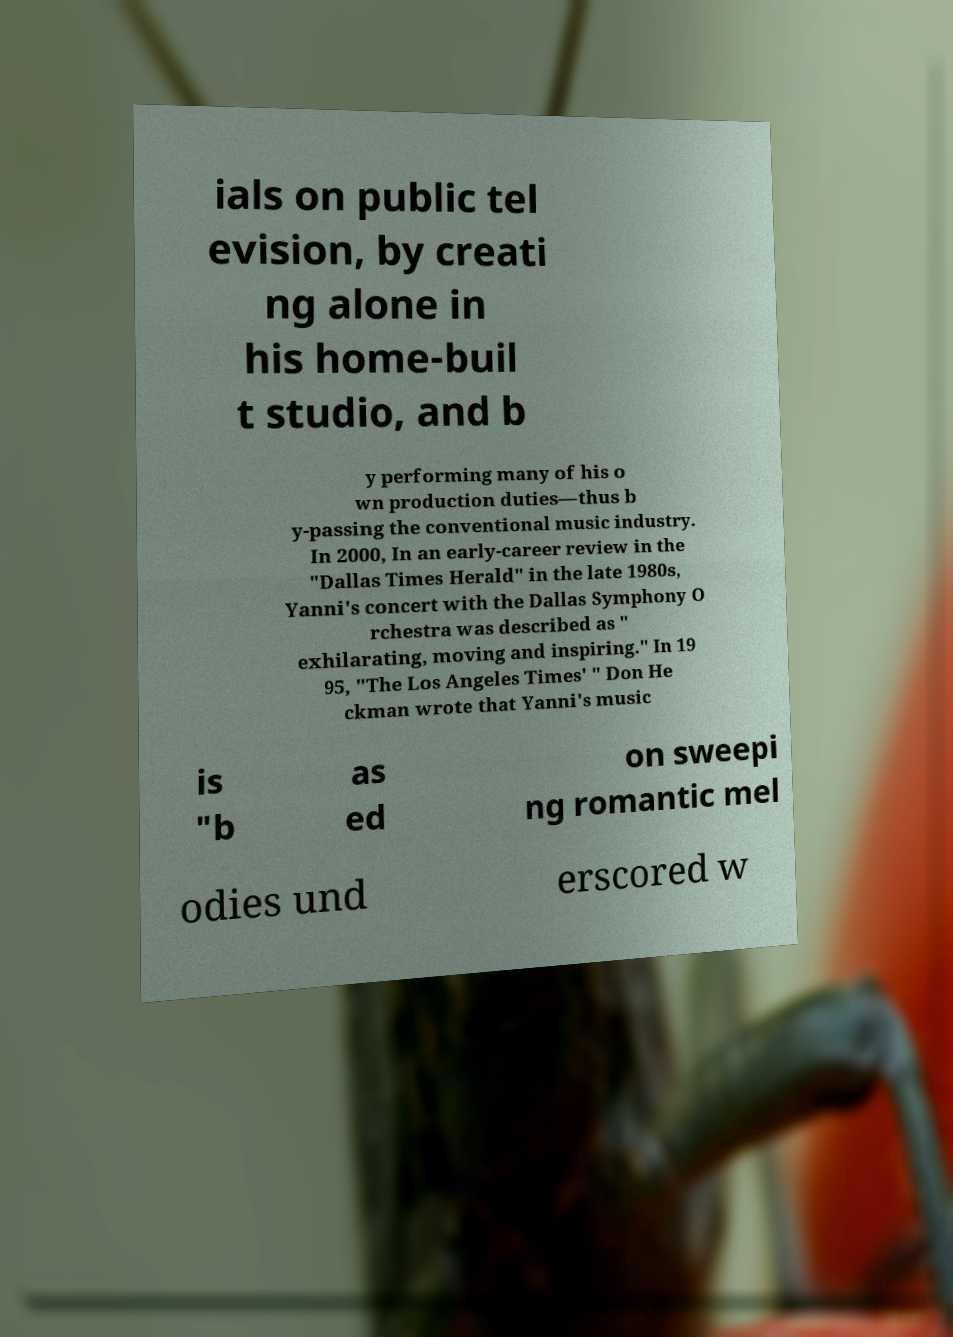Could you assist in decoding the text presented in this image and type it out clearly? ials on public tel evision, by creati ng alone in his home-buil t studio, and b y performing many of his o wn production duties—thus b y-passing the conventional music industry. In 2000, In an early-career review in the "Dallas Times Herald" in the late 1980s, Yanni's concert with the Dallas Symphony O rchestra was described as " exhilarating, moving and inspiring." In 19 95, "The Los Angeles Times' " Don He ckman wrote that Yanni's music is "b as ed on sweepi ng romantic mel odies und erscored w 